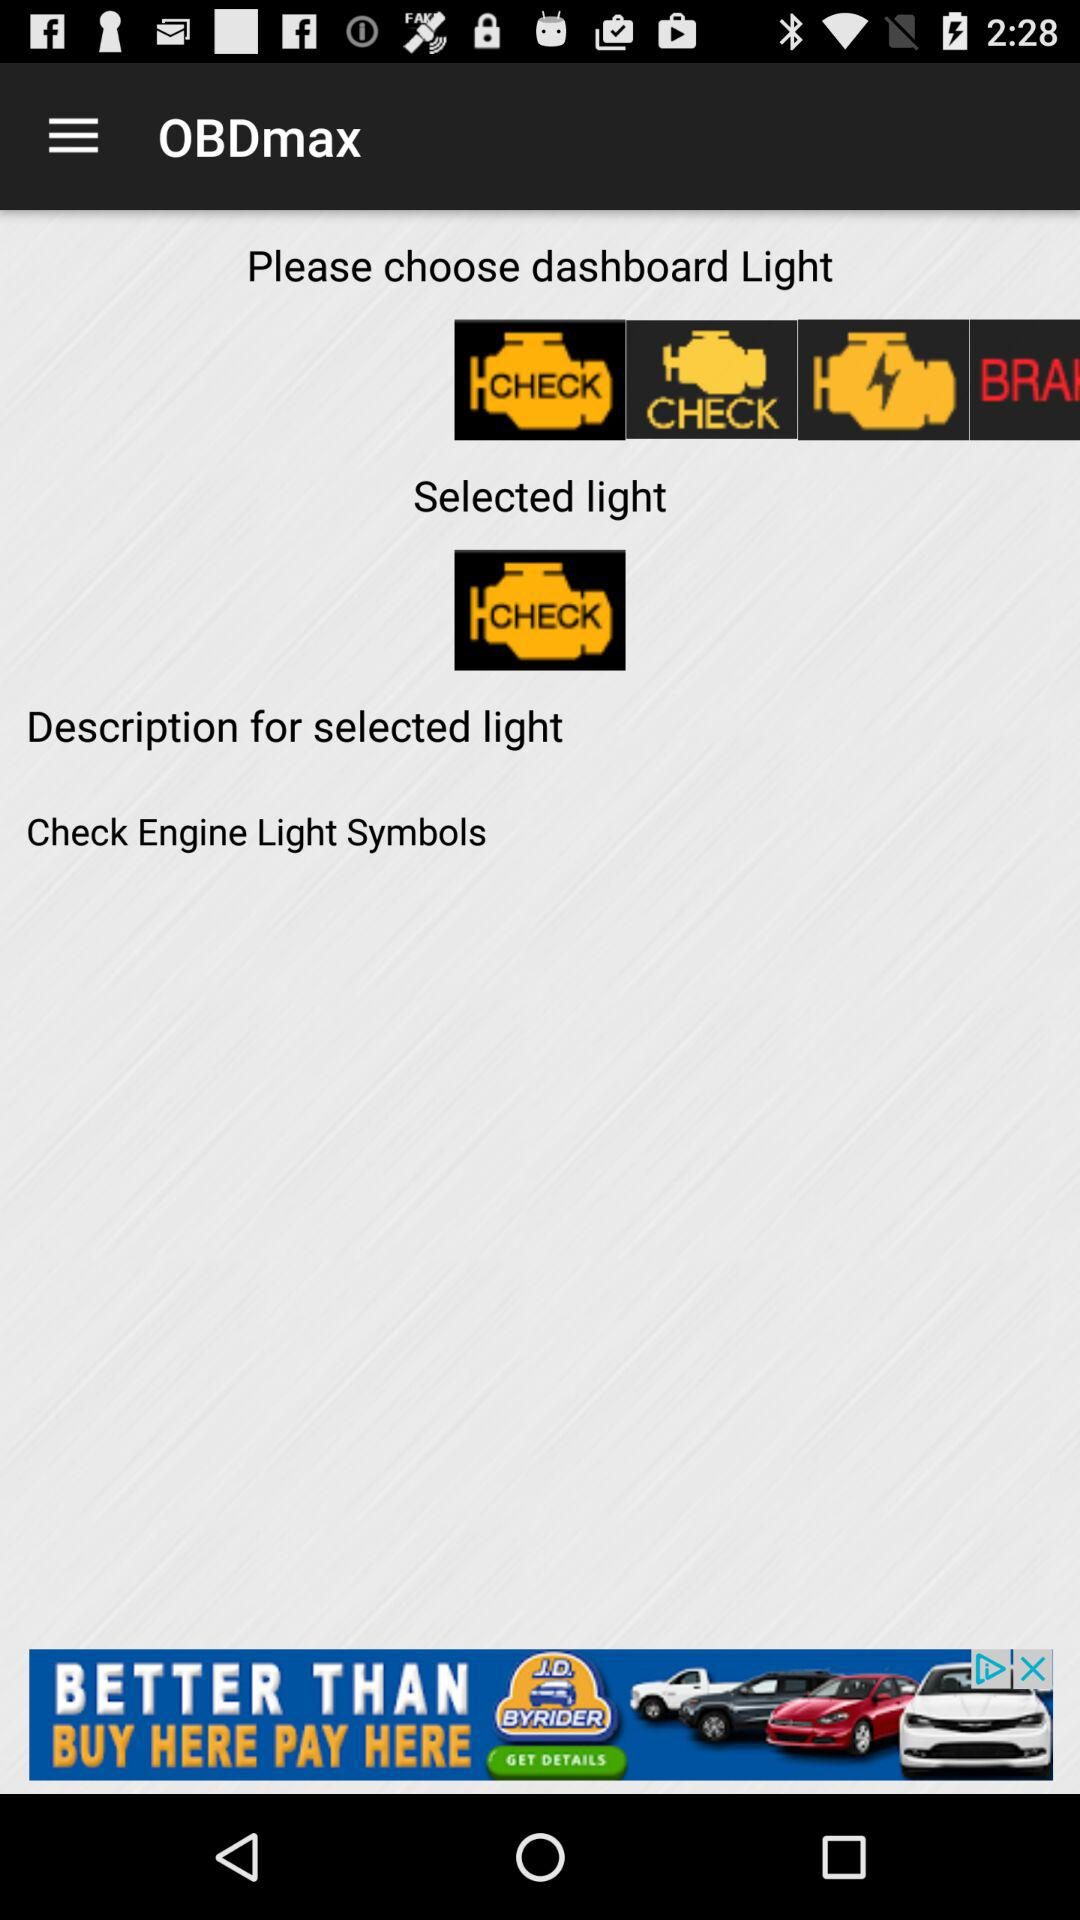What is the name of the application? The name of the application is "OBDmax". 